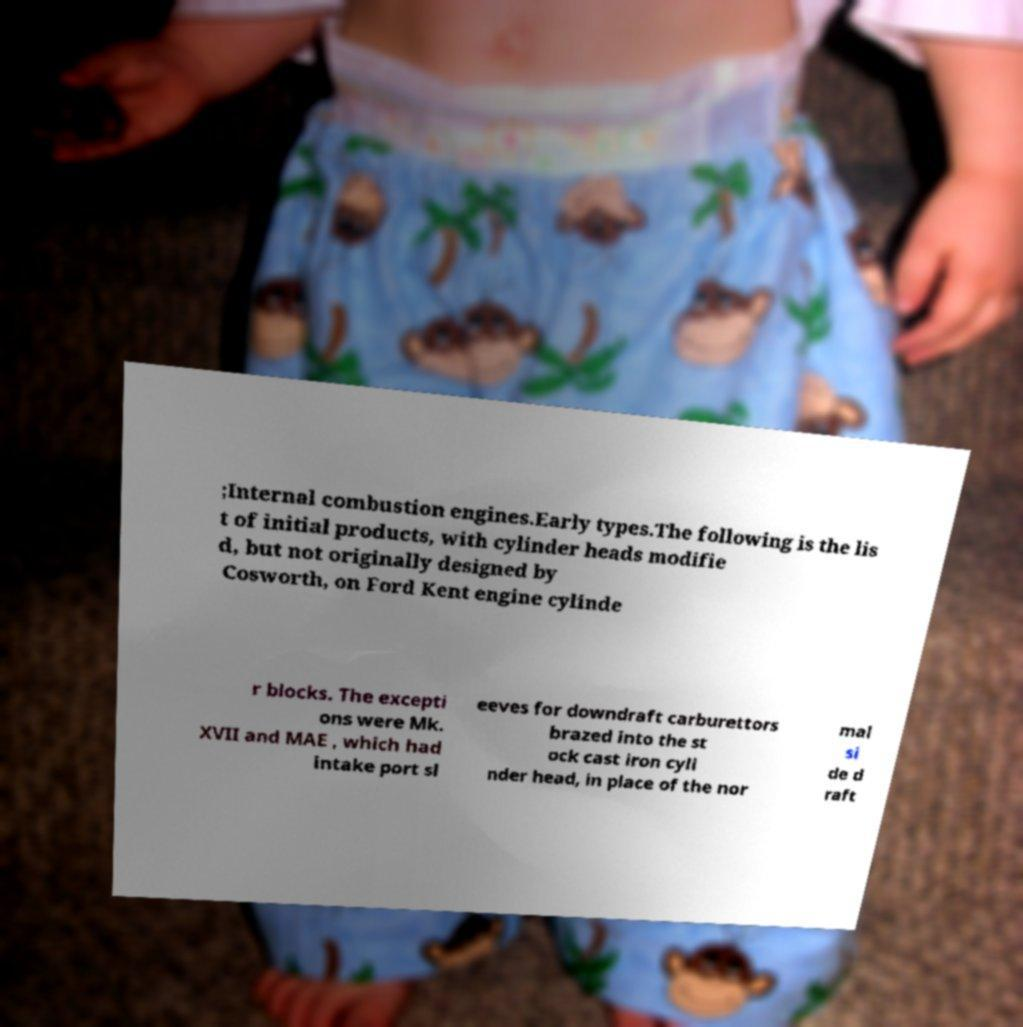Can you accurately transcribe the text from the provided image for me? ;Internal combustion engines.Early types.The following is the lis t of initial products, with cylinder heads modifie d, but not originally designed by Cosworth, on Ford Kent engine cylinde r blocks. The excepti ons were Mk. XVII and MAE , which had intake port sl eeves for downdraft carburettors brazed into the st ock cast iron cyli nder head, in place of the nor mal si de d raft 